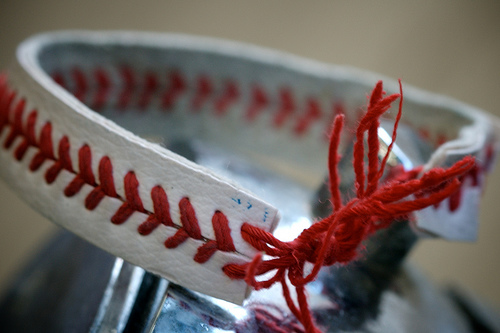<image>
Is the tie next to the ball? Yes. The tie is positioned adjacent to the ball, located nearby in the same general area. 